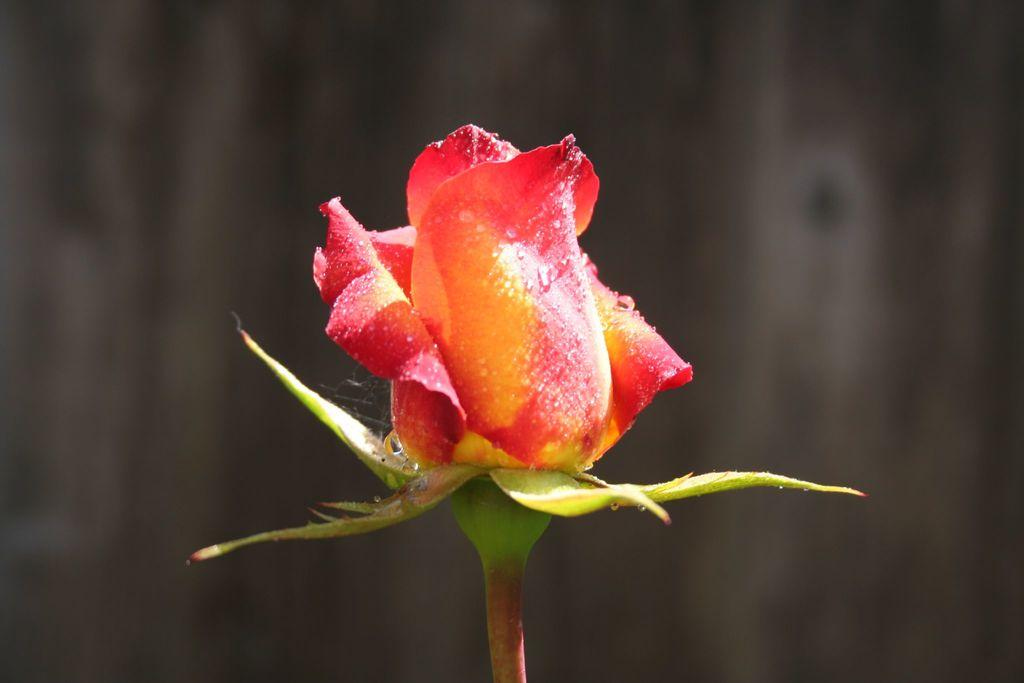What type of flower is present in the image? There is a rose bud in the image. How many beans are visible on the rose bud in the image? There are no beans present on the rose bud in the image. What color are the queen's toes in the image? There is no queen or reference to toes in the image; it only features a rose bud. 